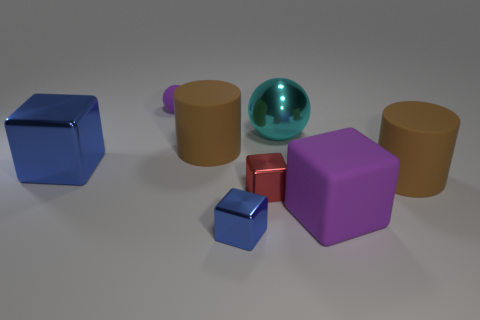Subtract all green cubes. Subtract all purple cylinders. How many cubes are left? 4 Add 2 large brown rubber things. How many objects exist? 10 Subtract all cylinders. How many objects are left? 6 Add 4 small purple spheres. How many small purple spheres are left? 5 Add 7 big blocks. How many big blocks exist? 9 Subtract 1 cyan balls. How many objects are left? 7 Subtract all big brown things. Subtract all big purple matte blocks. How many objects are left? 5 